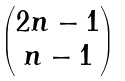<formula> <loc_0><loc_0><loc_500><loc_500>\begin{pmatrix} 2 n - 1 \\ n - 1 \end{pmatrix}</formula> 